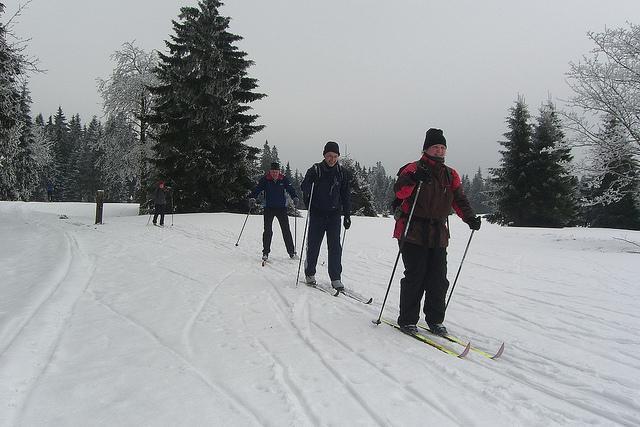What is needed for this activity?
Pick the correct solution from the four options below to address the question.
Options: Sun, sand, snow, rain. Snow. 